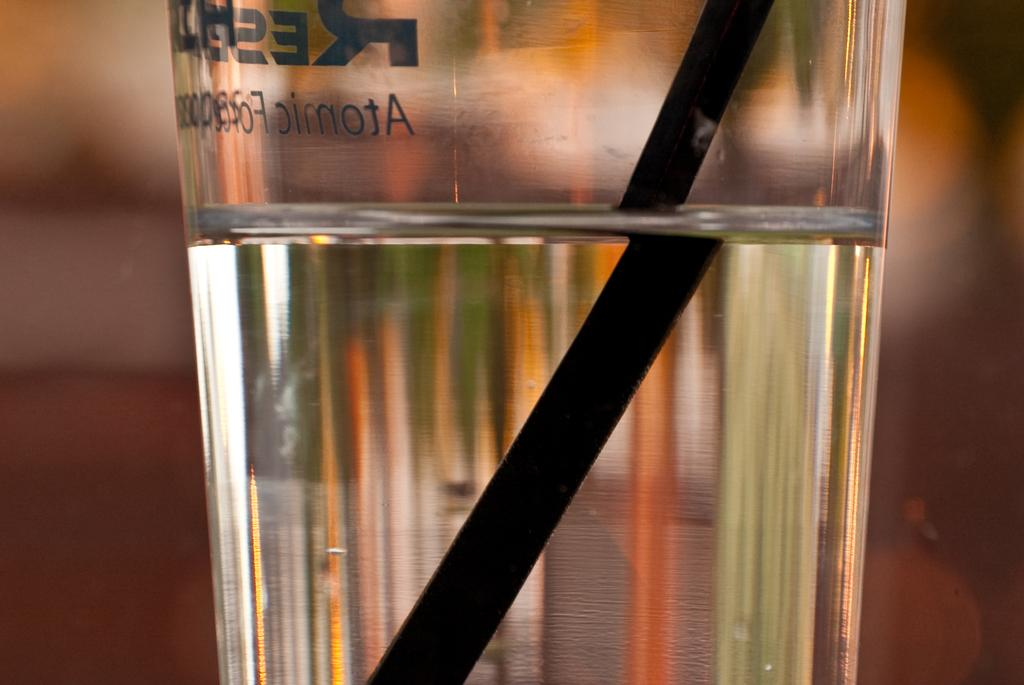What is in the glass that is visible in the image? The glass contains water. What object is inside the glass? There is a straw in the glass. What might be used to drink the water in the glass? The straw in the glass can be used to drink the water. What type of skin is visible on the glass in the image? There is no skin visible on the glass in the image; it is a glass containing water with a straw inside. 